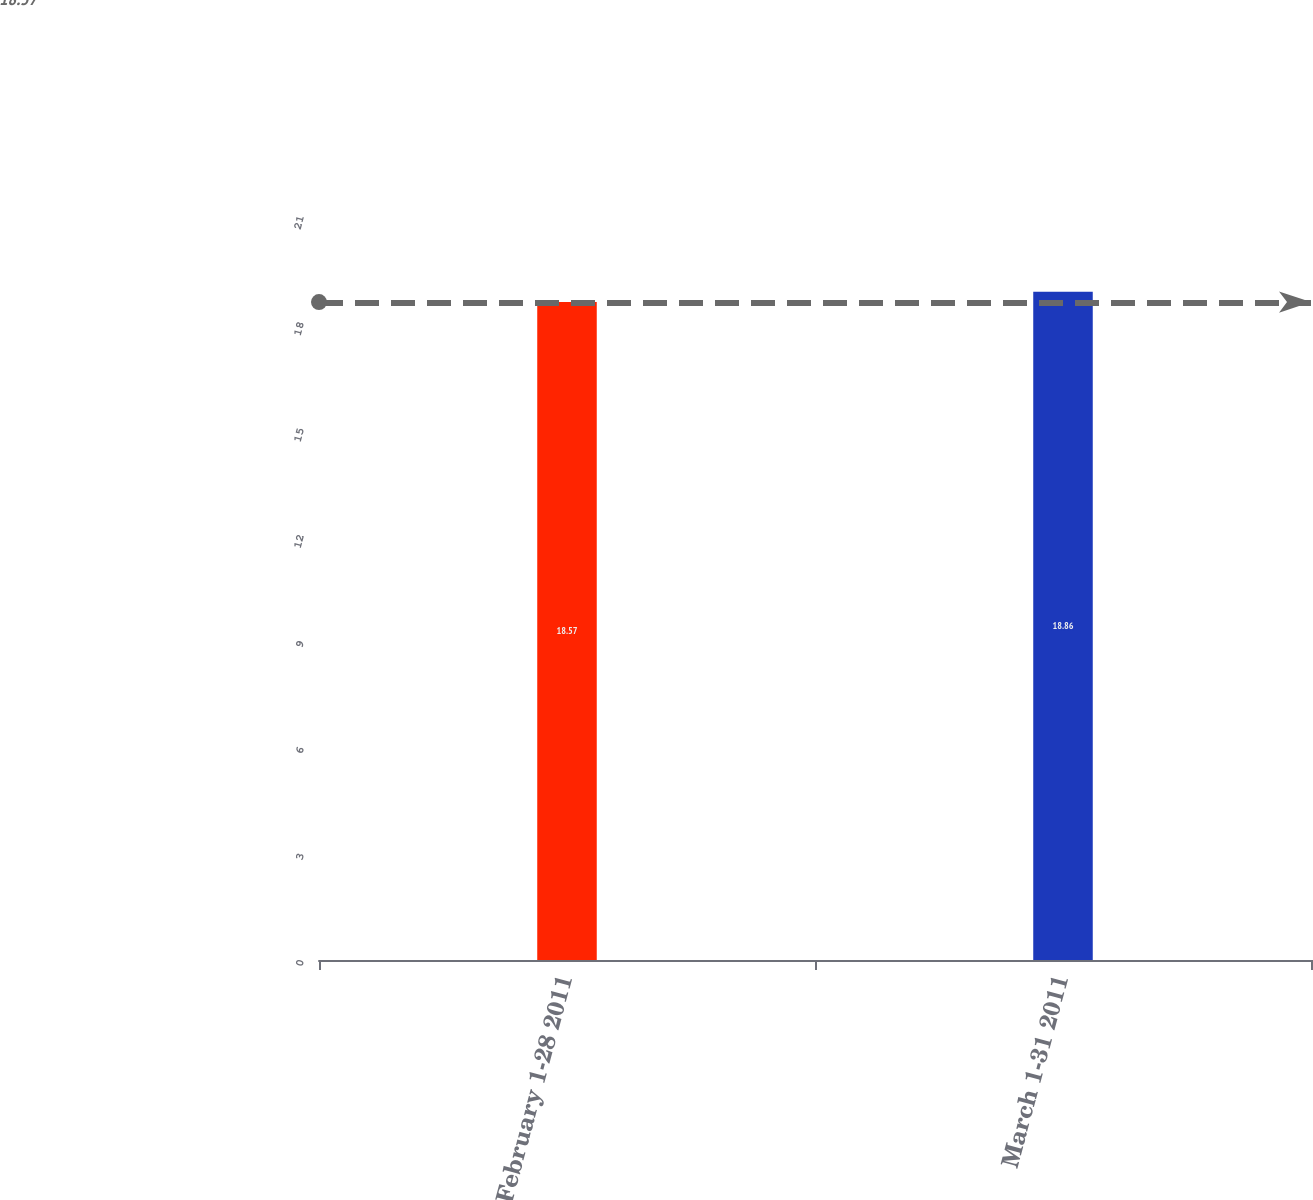<chart> <loc_0><loc_0><loc_500><loc_500><bar_chart><fcel>February 1-28 2011<fcel>March 1-31 2011<nl><fcel>18.57<fcel>18.86<nl></chart> 